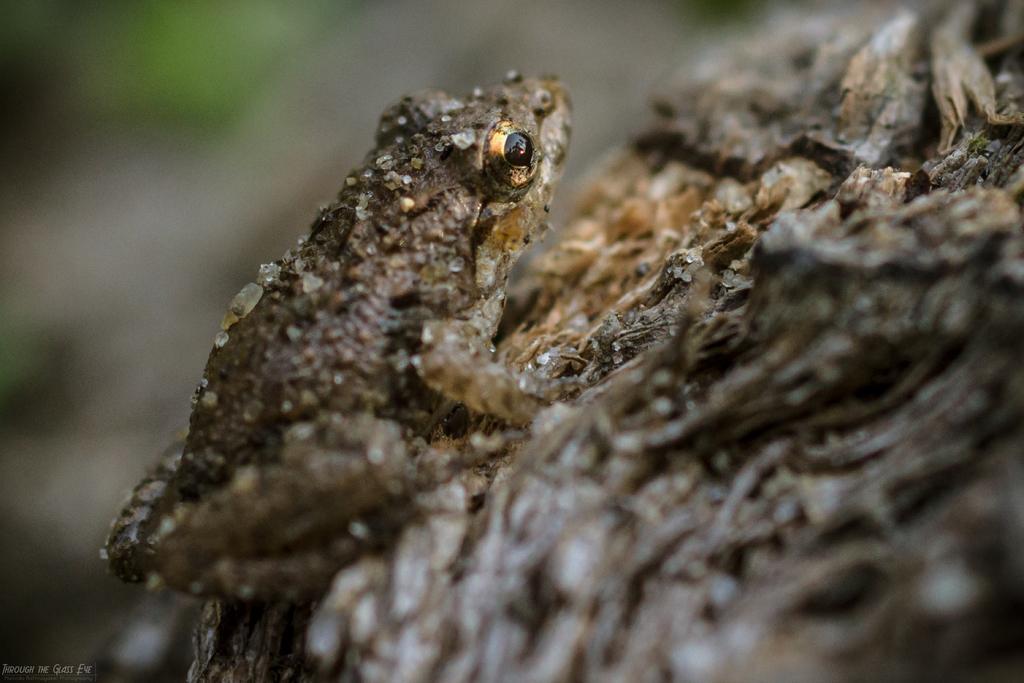In one or two sentences, can you explain what this image depicts? In this image I can see the frog in brown color and the frog is on the brown color surface and I can see the blurred background. 